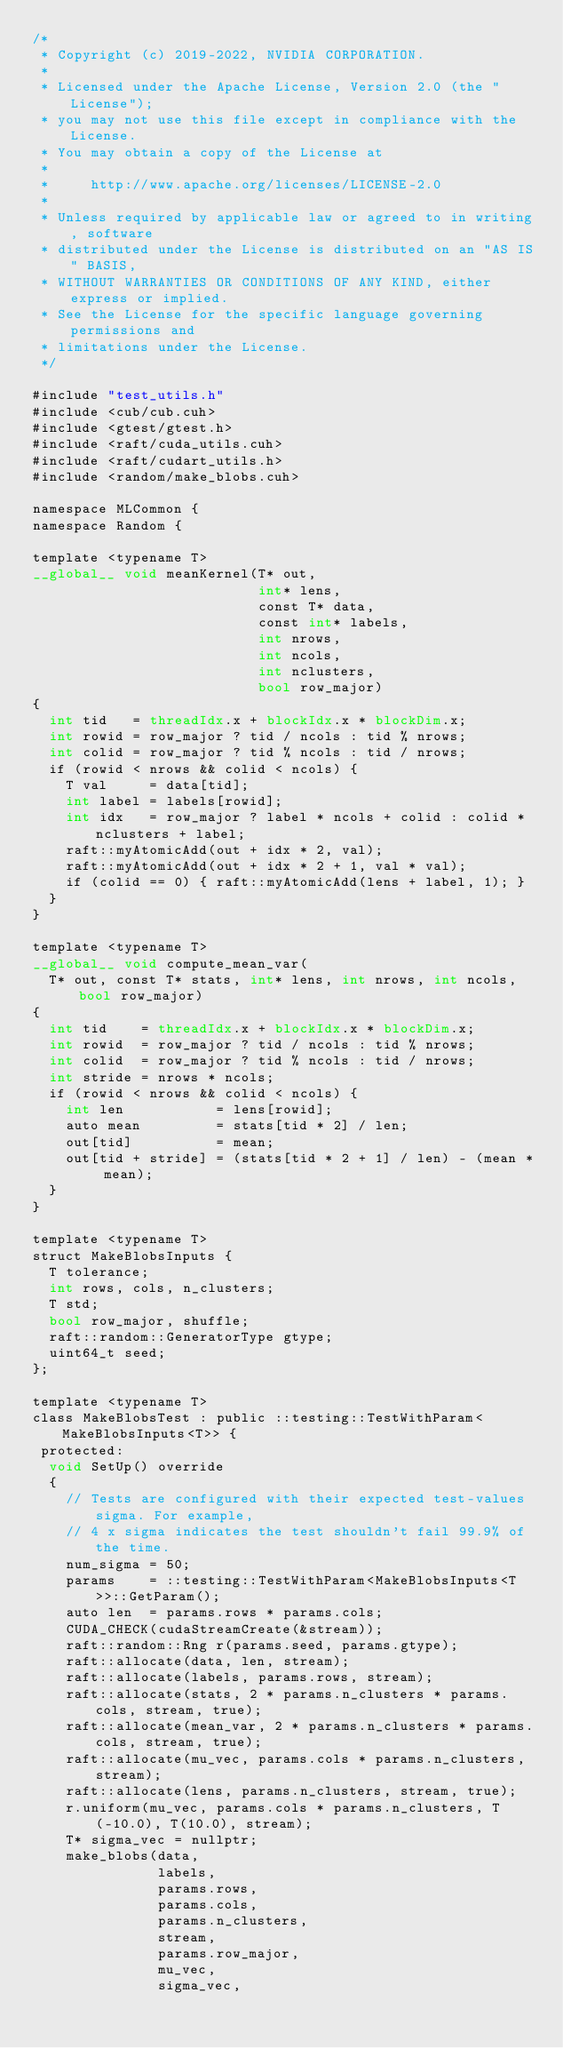Convert code to text. <code><loc_0><loc_0><loc_500><loc_500><_Cuda_>/*
 * Copyright (c) 2019-2022, NVIDIA CORPORATION.
 *
 * Licensed under the Apache License, Version 2.0 (the "License");
 * you may not use this file except in compliance with the License.
 * You may obtain a copy of the License at
 *
 *     http://www.apache.org/licenses/LICENSE-2.0
 *
 * Unless required by applicable law or agreed to in writing, software
 * distributed under the License is distributed on an "AS IS" BASIS,
 * WITHOUT WARRANTIES OR CONDITIONS OF ANY KIND, either express or implied.
 * See the License for the specific language governing permissions and
 * limitations under the License.
 */

#include "test_utils.h"
#include <cub/cub.cuh>
#include <gtest/gtest.h>
#include <raft/cuda_utils.cuh>
#include <raft/cudart_utils.h>
#include <random/make_blobs.cuh>

namespace MLCommon {
namespace Random {

template <typename T>
__global__ void meanKernel(T* out,
                           int* lens,
                           const T* data,
                           const int* labels,
                           int nrows,
                           int ncols,
                           int nclusters,
                           bool row_major)
{
  int tid   = threadIdx.x + blockIdx.x * blockDim.x;
  int rowid = row_major ? tid / ncols : tid % nrows;
  int colid = row_major ? tid % ncols : tid / nrows;
  if (rowid < nrows && colid < ncols) {
    T val     = data[tid];
    int label = labels[rowid];
    int idx   = row_major ? label * ncols + colid : colid * nclusters + label;
    raft::myAtomicAdd(out + idx * 2, val);
    raft::myAtomicAdd(out + idx * 2 + 1, val * val);
    if (colid == 0) { raft::myAtomicAdd(lens + label, 1); }
  }
}

template <typename T>
__global__ void compute_mean_var(
  T* out, const T* stats, int* lens, int nrows, int ncols, bool row_major)
{
  int tid    = threadIdx.x + blockIdx.x * blockDim.x;
  int rowid  = row_major ? tid / ncols : tid % nrows;
  int colid  = row_major ? tid % ncols : tid / nrows;
  int stride = nrows * ncols;
  if (rowid < nrows && colid < ncols) {
    int len           = lens[rowid];
    auto mean         = stats[tid * 2] / len;
    out[tid]          = mean;
    out[tid + stride] = (stats[tid * 2 + 1] / len) - (mean * mean);
  }
}

template <typename T>
struct MakeBlobsInputs {
  T tolerance;
  int rows, cols, n_clusters;
  T std;
  bool row_major, shuffle;
  raft::random::GeneratorType gtype;
  uint64_t seed;
};

template <typename T>
class MakeBlobsTest : public ::testing::TestWithParam<MakeBlobsInputs<T>> {
 protected:
  void SetUp() override
  {
    // Tests are configured with their expected test-values sigma. For example,
    // 4 x sigma indicates the test shouldn't fail 99.9% of the time.
    num_sigma = 50;
    params    = ::testing::TestWithParam<MakeBlobsInputs<T>>::GetParam();
    auto len  = params.rows * params.cols;
    CUDA_CHECK(cudaStreamCreate(&stream));
    raft::random::Rng r(params.seed, params.gtype);
    raft::allocate(data, len, stream);
    raft::allocate(labels, params.rows, stream);
    raft::allocate(stats, 2 * params.n_clusters * params.cols, stream, true);
    raft::allocate(mean_var, 2 * params.n_clusters * params.cols, stream, true);
    raft::allocate(mu_vec, params.cols * params.n_clusters, stream);
    raft::allocate(lens, params.n_clusters, stream, true);
    r.uniform(mu_vec, params.cols * params.n_clusters, T(-10.0), T(10.0), stream);
    T* sigma_vec = nullptr;
    make_blobs(data,
               labels,
               params.rows,
               params.cols,
               params.n_clusters,
               stream,
               params.row_major,
               mu_vec,
               sigma_vec,</code> 